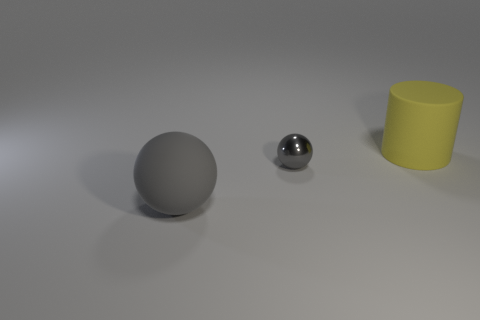Add 2 tiny yellow matte balls. How many objects exist? 5 Subtract all cylinders. How many objects are left? 2 Subtract all large green objects. Subtract all small gray things. How many objects are left? 2 Add 1 yellow cylinders. How many yellow cylinders are left? 2 Add 3 small red blocks. How many small red blocks exist? 3 Subtract 0 red blocks. How many objects are left? 3 